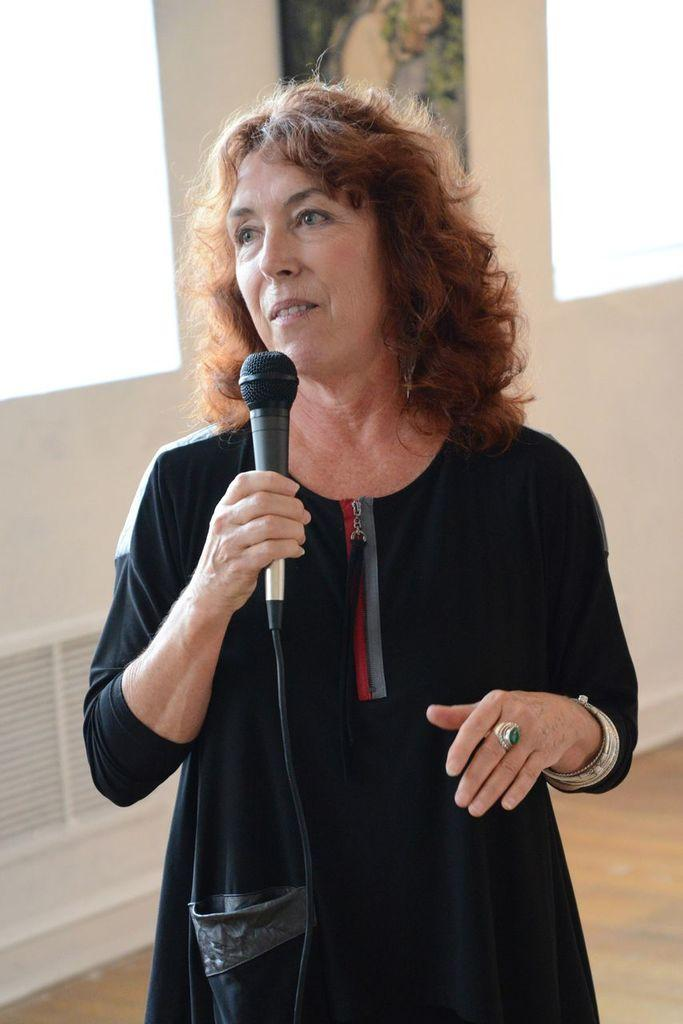Who is the main subject in the image? There is a woman in the image. What is the woman doing in the image? The woman is standing on the floor and holding a mic in one of her hands. What can be seen in the background of the image? There is a wall in the background of the image. What type of sign is the woman holding in the image? There is no sign present in the image; the woman is holding a mic. What is the condition of the woman's pet in the image? There is no pet present in the image. 